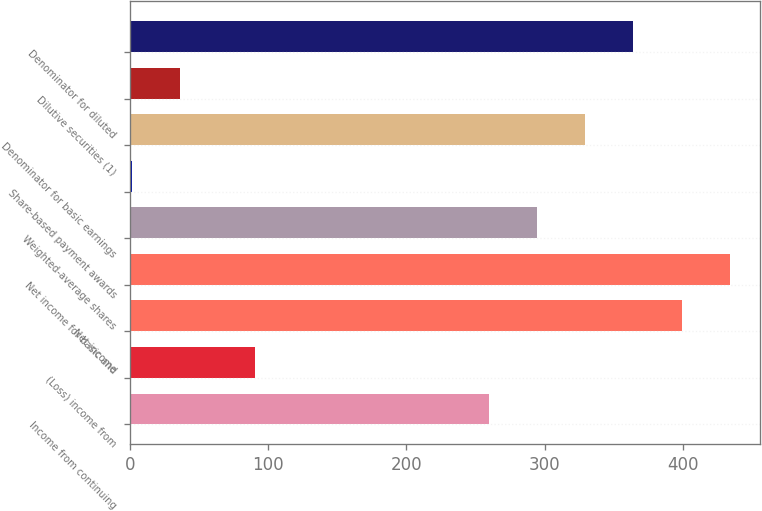Convert chart to OTSL. <chart><loc_0><loc_0><loc_500><loc_500><bar_chart><fcel>Income from continuing<fcel>(Loss) income from<fcel>Net income<fcel>Net income for basic and<fcel>Weighted-average shares<fcel>Share-based payment awards<fcel>Denominator for basic earnings<fcel>Dilutive securities (1)<fcel>Denominator for diluted<nl><fcel>259.3<fcel>90.7<fcel>398.78<fcel>433.65<fcel>294.17<fcel>1.4<fcel>329.04<fcel>36.27<fcel>363.91<nl></chart> 